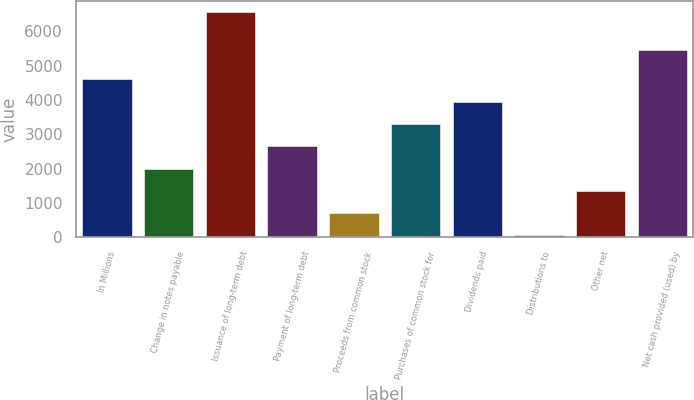<chart> <loc_0><loc_0><loc_500><loc_500><bar_chart><fcel>In Millions<fcel>Change in notes payable<fcel>Issuance of long-term debt<fcel>Payment of long-term debt<fcel>Proceeds from common stock<fcel>Purchases of common stock for<fcel>Dividends paid<fcel>Distributions to<fcel>Other net<fcel>Net cash provided (used) by<nl><fcel>4600.54<fcel>2001.26<fcel>6550<fcel>2651.08<fcel>701.62<fcel>3300.9<fcel>3950.72<fcel>51.8<fcel>1351.44<fcel>5445.5<nl></chart> 